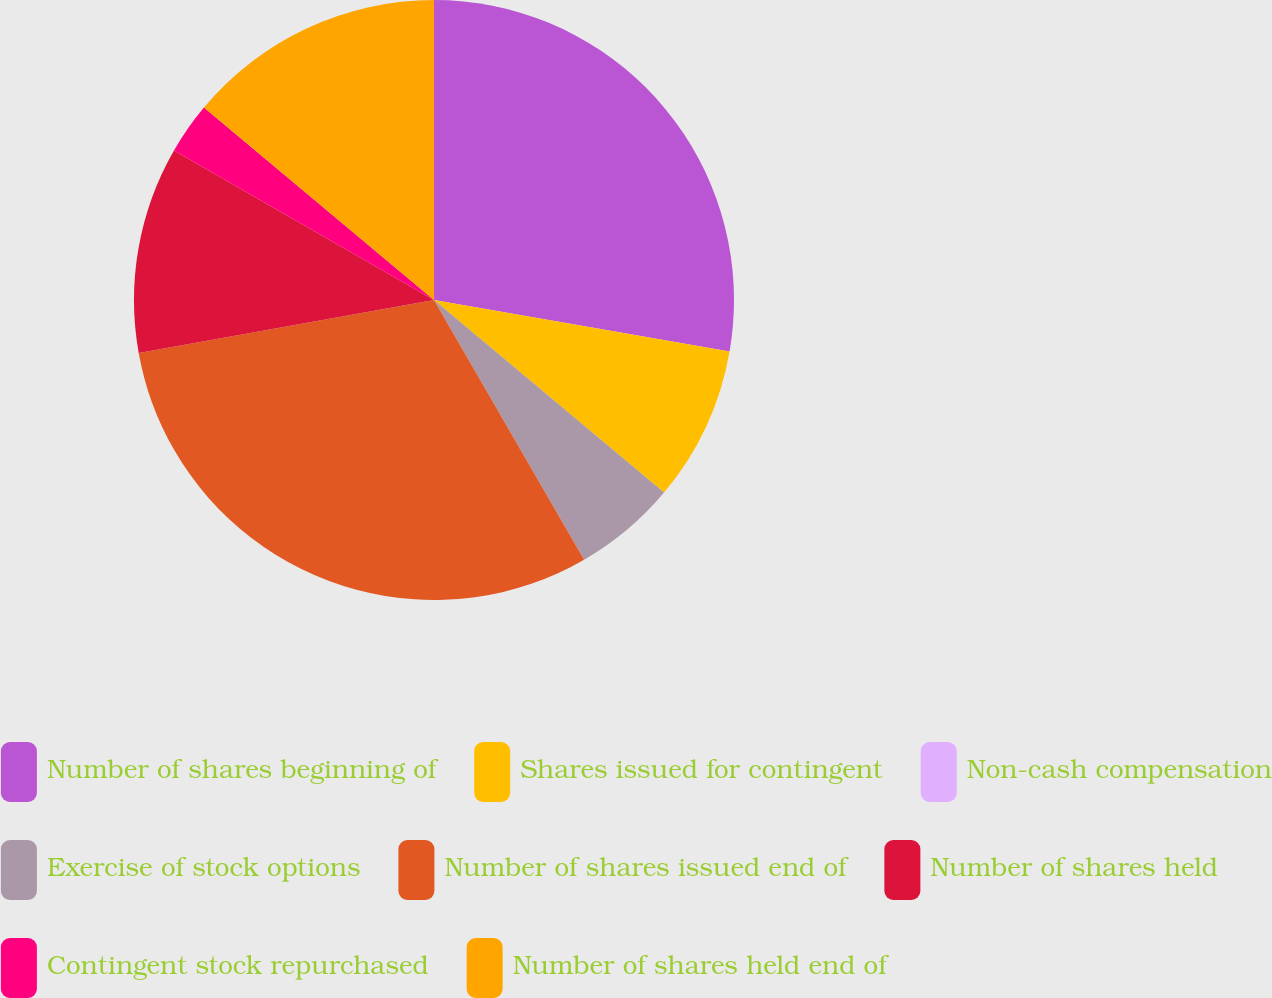Convert chart. <chart><loc_0><loc_0><loc_500><loc_500><pie_chart><fcel>Number of shares beginning of<fcel>Shares issued for contingent<fcel>Non-cash compensation<fcel>Exercise of stock options<fcel>Number of shares issued end of<fcel>Number of shares held<fcel>Contingent stock repurchased<fcel>Number of shares held end of<nl><fcel>27.74%<fcel>8.35%<fcel>0.0%<fcel>5.57%<fcel>30.52%<fcel>11.13%<fcel>2.78%<fcel>13.91%<nl></chart> 